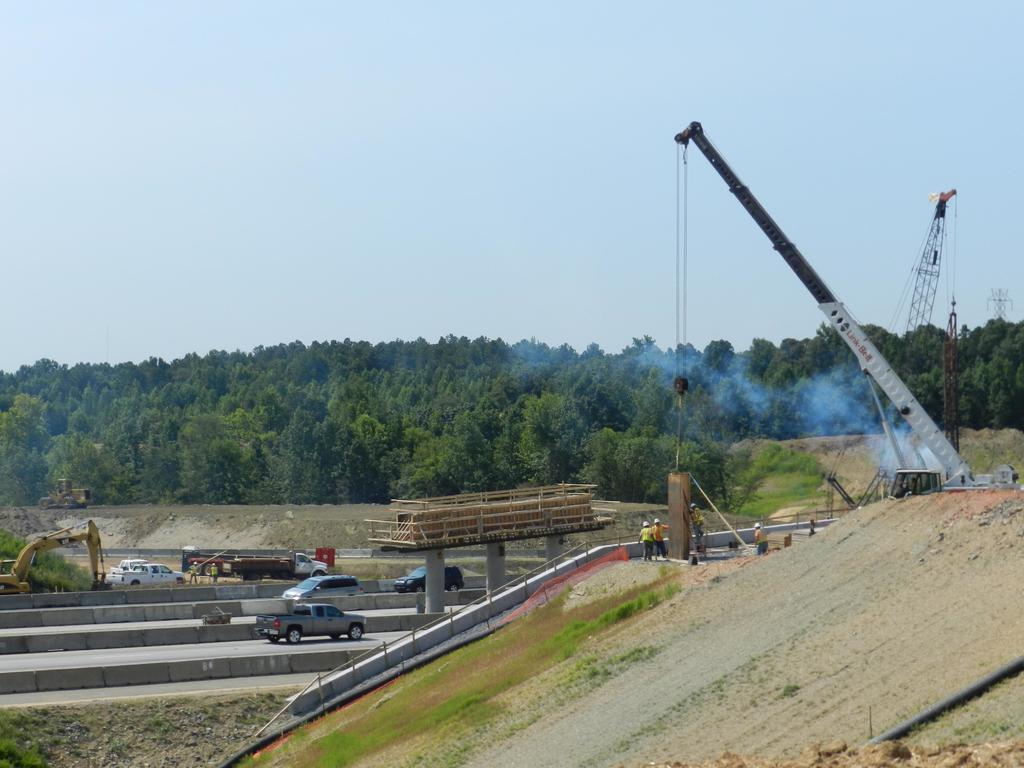What type of large machines can be seen in the image? There are cranes in the image. What architectural features are present in the image? There are pillars in the image. What type of transportation infrastructure is visible in the image? There are roads in the image. What type of vehicles can be seen in the image? There are vehicles in the image. What type of natural environment is visible in the image? There is grass in the image. What type of atmospheric phenomenon is visible in the image? There is smoke in the image. What type of living organisms can be seen in the image? There are people in the image. What type of vegetation is visible in the image? There are trees in the image. What part of the natural environment is visible in the image? The sky is visible in the image. What type of objects are present in the image? There are objects in the image. Where is the zoo located in the image? There is no zoo present in the image. What type of container is used for bathing in the image? There is no tub present in the image. What type of substance is being used for cleaning in the image? There is no powder present in the image. 